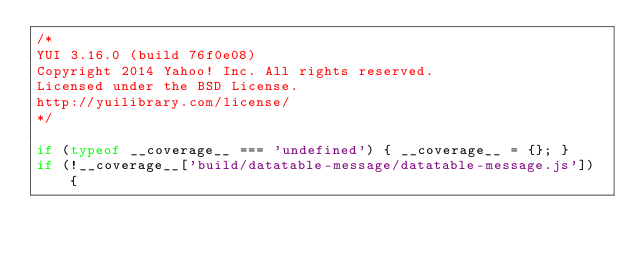<code> <loc_0><loc_0><loc_500><loc_500><_JavaScript_>/*
YUI 3.16.0 (build 76f0e08)
Copyright 2014 Yahoo! Inc. All rights reserved.
Licensed under the BSD License.
http://yuilibrary.com/license/
*/

if (typeof __coverage__ === 'undefined') { __coverage__ = {}; }
if (!__coverage__['build/datatable-message/datatable-message.js']) {</code> 